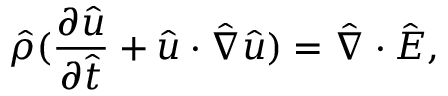Convert formula to latex. <formula><loc_0><loc_0><loc_500><loc_500>\hat { \rho } ( \frac { \partial \hat { u } } { \partial \hat { t } } + \hat { u } \cdot \hat { \nabla } \hat { u } ) = \hat { \nabla } \cdot \hat { E } ,</formula> 